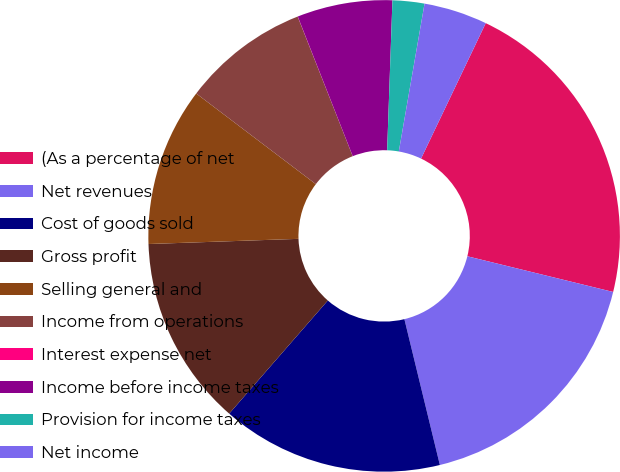Convert chart to OTSL. <chart><loc_0><loc_0><loc_500><loc_500><pie_chart><fcel>(As a percentage of net<fcel>Net revenues<fcel>Cost of goods sold<fcel>Gross profit<fcel>Selling general and<fcel>Income from operations<fcel>Interest expense net<fcel>Income before income taxes<fcel>Provision for income taxes<fcel>Net income<nl><fcel>21.73%<fcel>17.38%<fcel>15.21%<fcel>13.04%<fcel>10.87%<fcel>8.7%<fcel>0.01%<fcel>6.53%<fcel>2.18%<fcel>4.35%<nl></chart> 